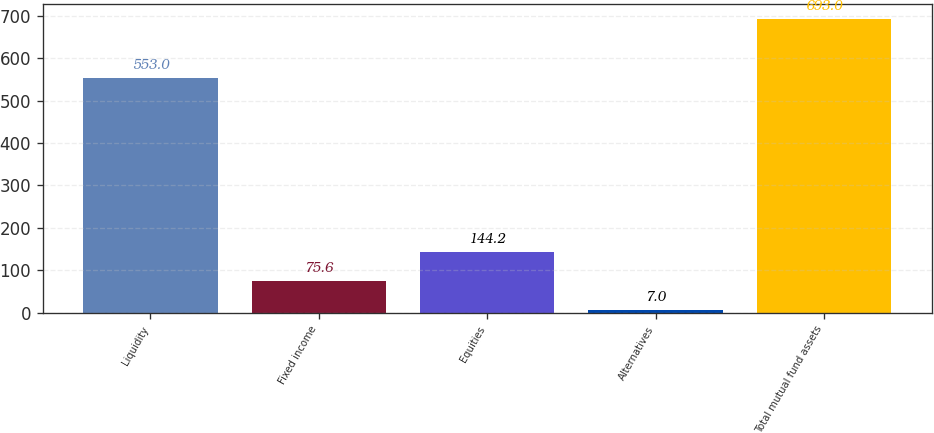Convert chart. <chart><loc_0><loc_0><loc_500><loc_500><bar_chart><fcel>Liquidity<fcel>Fixed income<fcel>Equities<fcel>Alternatives<fcel>Total mutual fund assets<nl><fcel>553<fcel>75.6<fcel>144.2<fcel>7<fcel>693<nl></chart> 